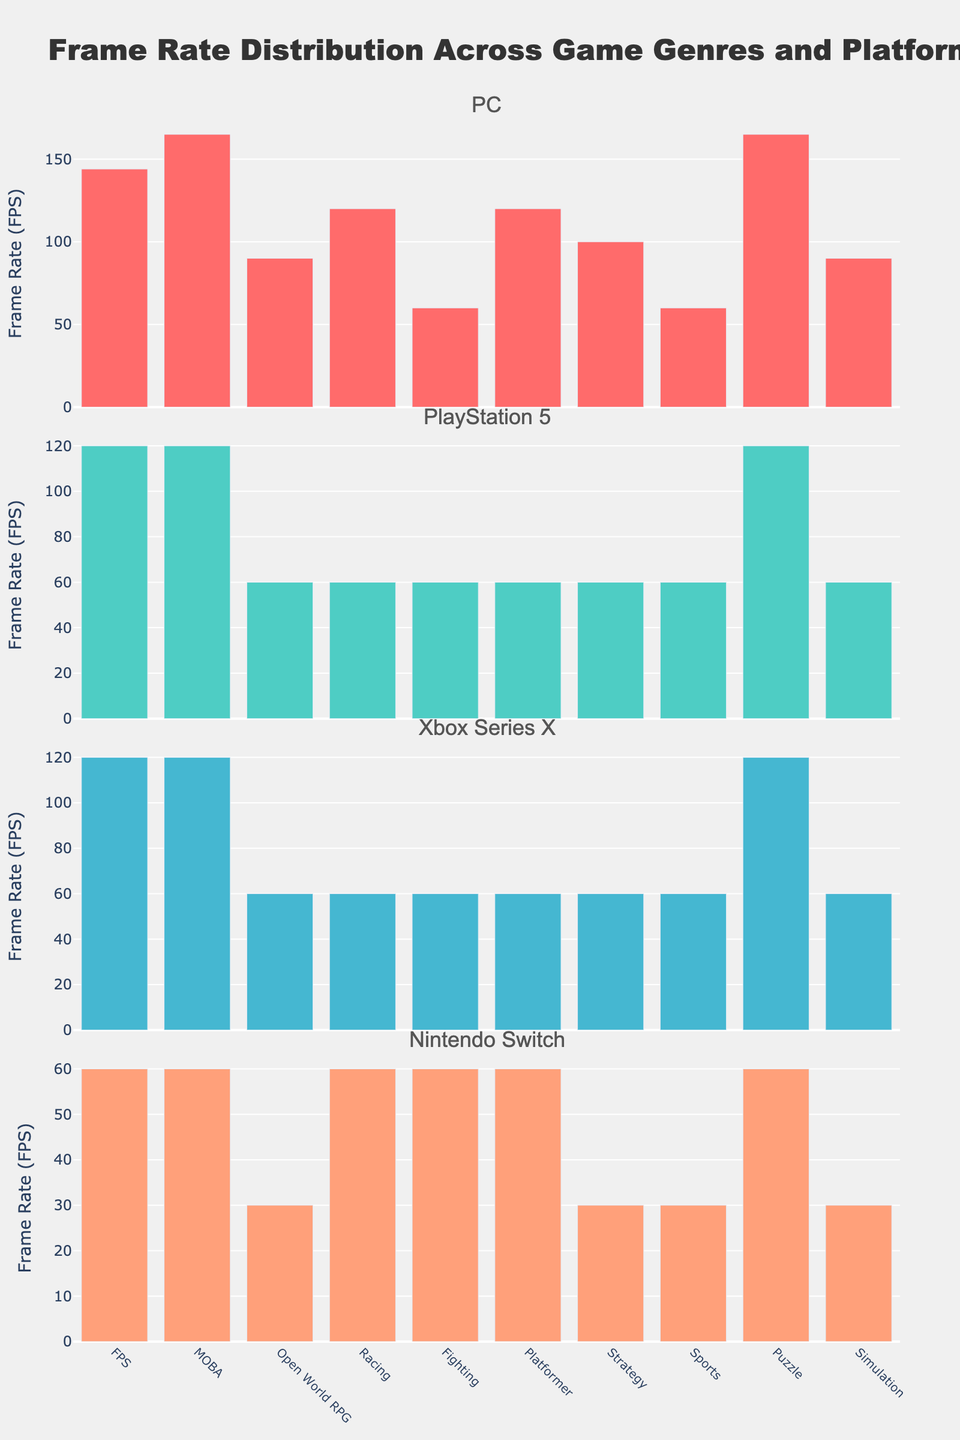What is the title of the figure? The title of the figure is displayed prominently at the top. It reads "Frame Rate Distribution Across Game Genres and Platforms".
Answer: Frame Rate Distribution Across Game Genres and Platforms How many platforms are compared in the figure? The figure consists of vertical subplots for four different platforms, each indicated by their respective subplot titles.
Answer: Four Which game genre has the lowest frame rate on PC? By inspecting the bars for the PC subplot, the lowest value corresponds to the Fighting and Sports genres.
Answer: Fighting, Sports What is the frame rate difference between PC and Nintendo Switch for the FPS genre? For the FPS genre, the PC frame rate is 144 FPS and for the Nintendo Switch, it's 60 FPS. The difference is 144 - 60.
Answer: 84 FPS Which platform generally has the highest frame rates across all genres? By comparing the heights of the bars across all the subplots, it's clear that the PC has the highest frame rates in most genres.
Answer: PC On the PlayStation 5, which genres have the same frame rate? By looking at the frame rates for PlayStation 5, FPS, MOBA, and Puzzle all have 120 FPS; Open World RPG, Racing, Fighting, Platformer, Strategy, Sports, and Simulation have 60 FPS.
Answer: Open World RPG, Racing, Fighting, Platformer, Strategy, Sports, Simulation What is the average frame rate of the Racing genre across all platforms? The Racing frame rates are PC: 120, PlayStation 5: 60, Xbox Series X: 60, Nintendo Switch: 60. The average is (120 + 60 + 60 + 60) / 4 = 75.
Answer: 75 FPS For which genre is the difference in frame rate between Xbox Series X and PlayStation 5 the smallest? By comparing the frame rates for Xbox Series X and PlayStation 5, the smallest difference is found in genres where both platforms have the same values. Fighting, Racing, and Platformer all have the same frame rate of 60 FPS on both platforms.
Answer: Fighting, Racing, Platformer Which genre has the highest frame rate on the Nintendo Switch? The highest frame rate for the Nintendo Switch, indicated by the tallest bar in the Nintendo Switch subplot, is associated with the FPS genre, which has a frame rate of 60 FPS.
Answer: FPS How does the frame rate of Simulation games on the PlayStation 5 compare to that on the PC? The frame rate for Simulation games is 60 FPS on the PlayStation 5 and 90 FPS on the PC. The frame rate on the PC is higher by 30 FPS.
Answer: PC is higher by 30 FPS 